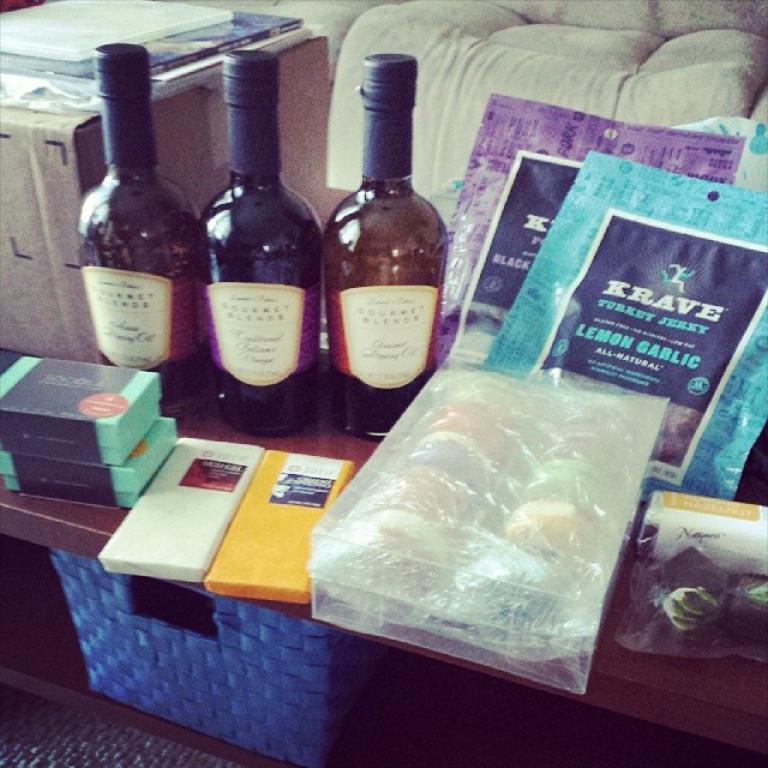<image>
Give a short and clear explanation of the subsequent image. Packets of Krave sit with some bottles and other items. 